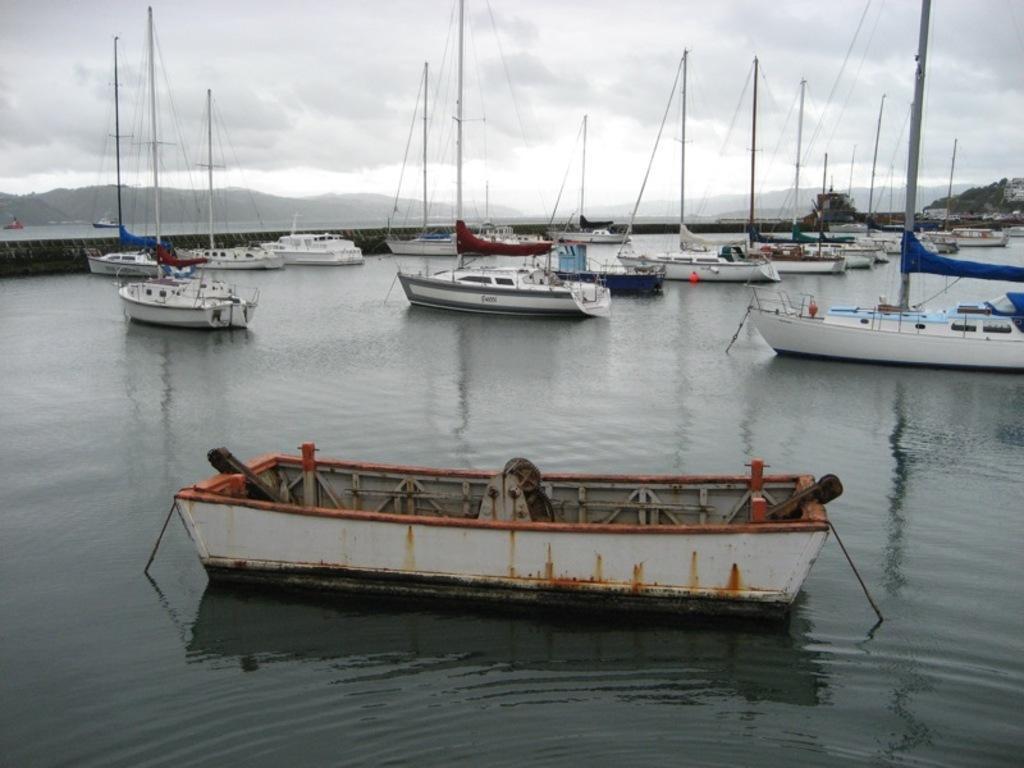Describe this image in one or two sentences. In this image we can see some boats with poles and wires in a large water body. We can also see a bridge, trees and a building. On the backside we can see the hills and the sky which looks cloudy. 